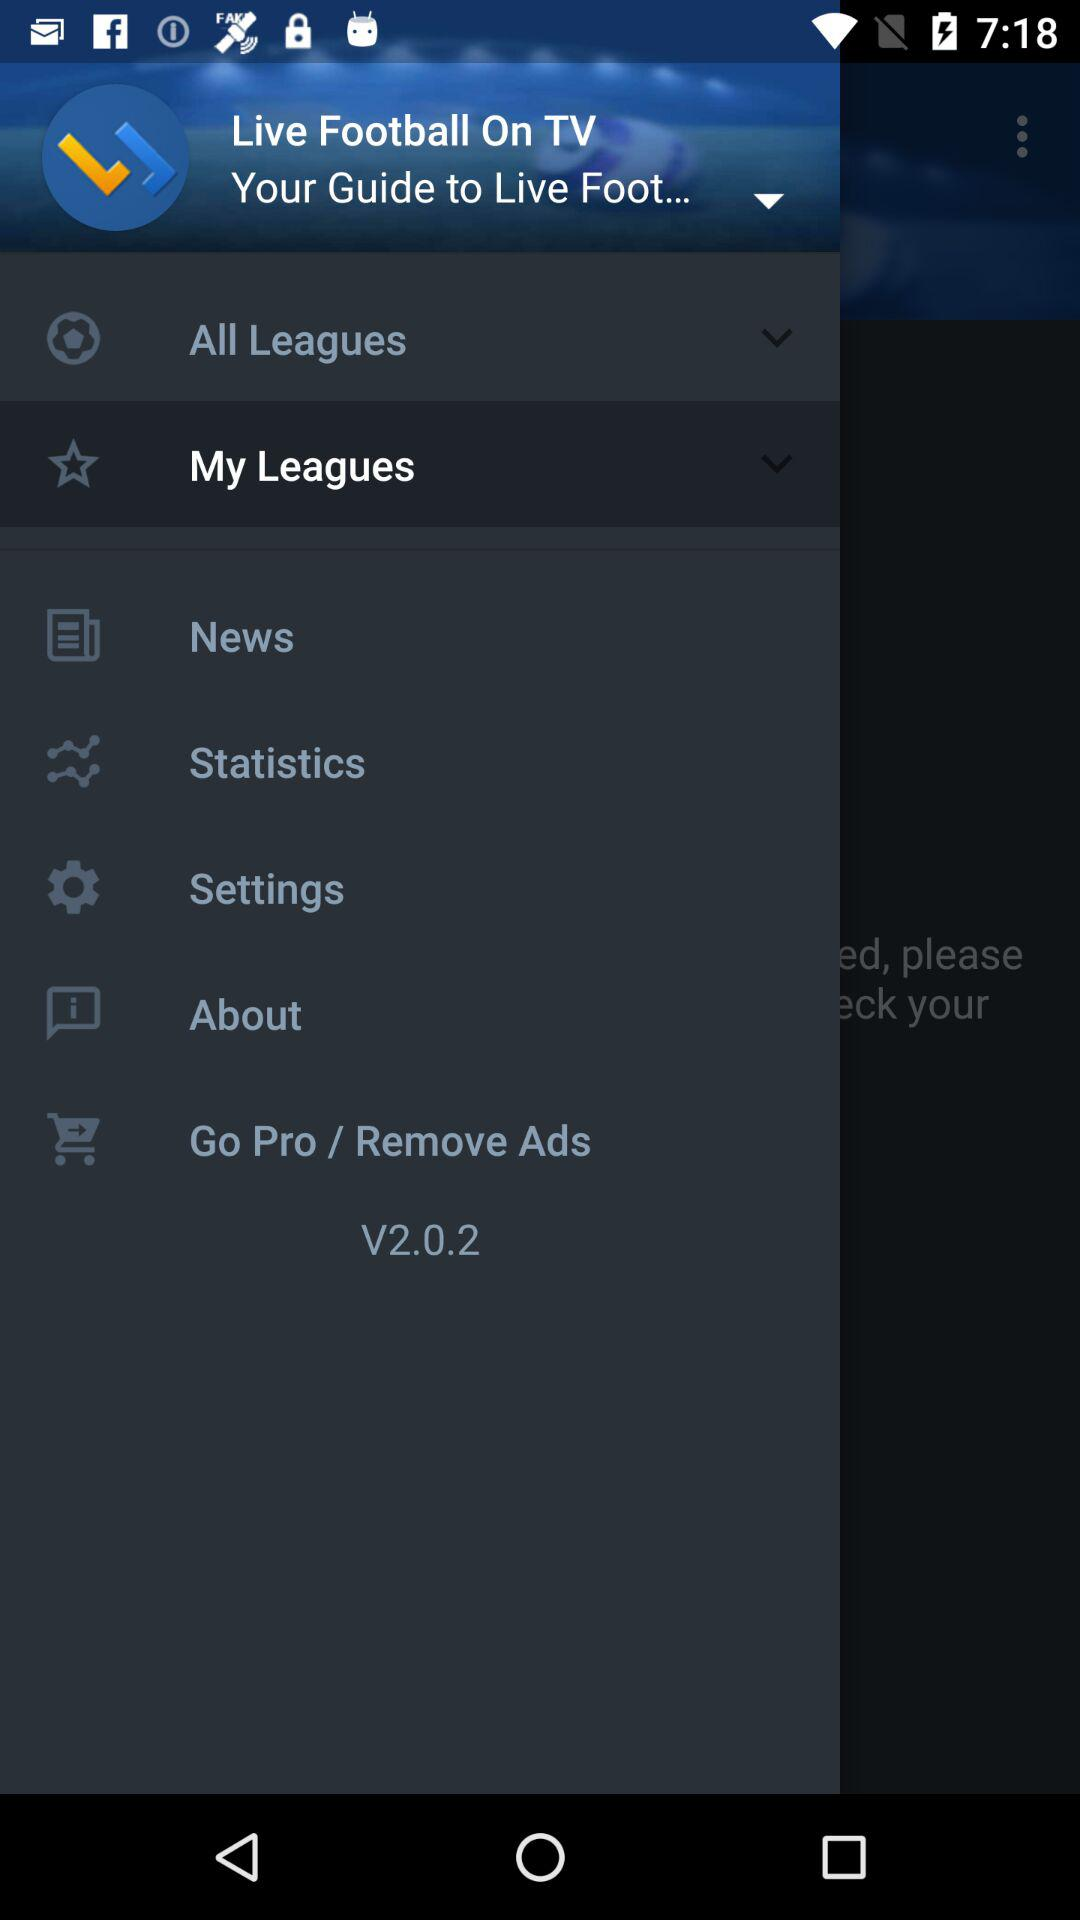What is the application's name? The application's name is "Live Football On TV". 